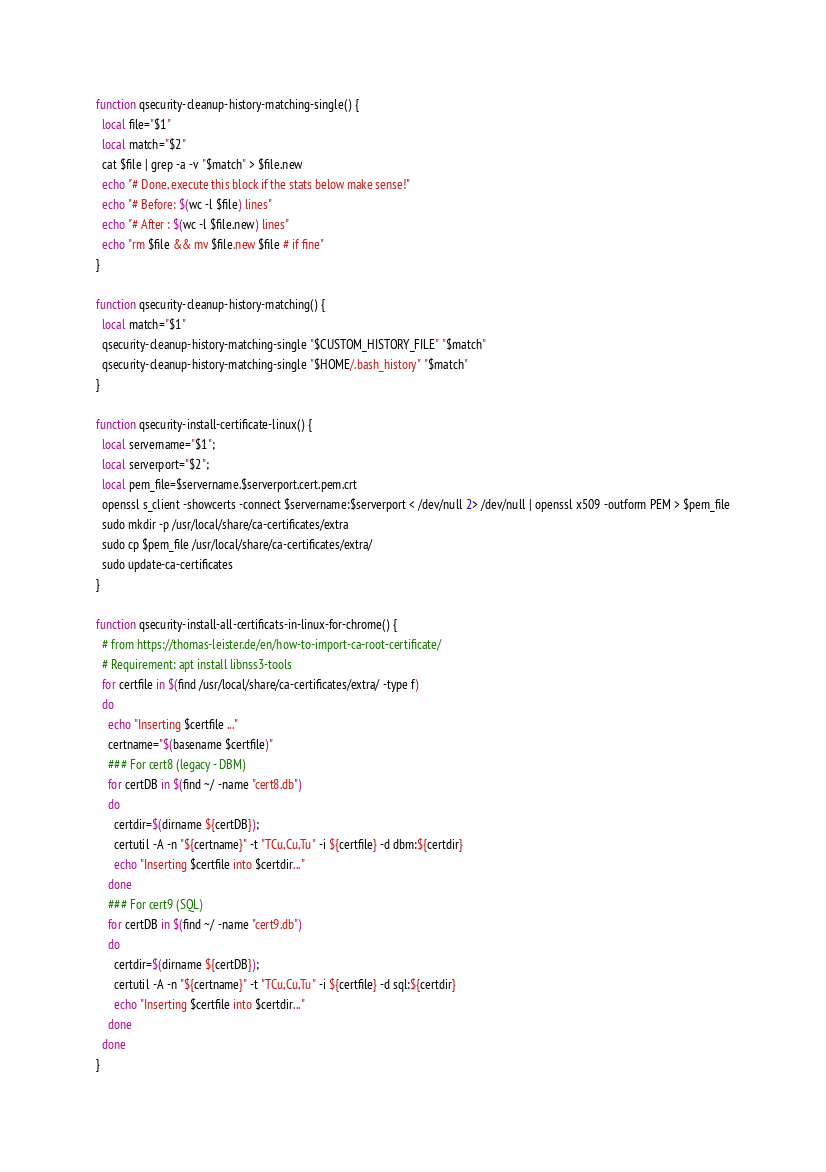<code> <loc_0><loc_0><loc_500><loc_500><_Bash_>function qsecurity-cleanup-history-matching-single() {
  local file="$1"
  local match="$2"
  cat $file | grep -a -v "$match" > $file.new
  echo "# Done, execute this block if the stats below make sense!"
  echo "# Before: $(wc -l $file) lines"
  echo "# After : $(wc -l $file.new) lines"
  echo "rm $file && mv $file.new $file # if fine"
}

function qsecurity-cleanup-history-matching() {
  local match="$1"
  qsecurity-cleanup-history-matching-single "$CUSTOM_HISTORY_FILE" "$match"
  qsecurity-cleanup-history-matching-single "$HOME/.bash_history" "$match"
}

function qsecurity-install-certificate-linux() {
  local servername="$1";
  local serverport="$2";
  local pem_file=$servername.$serverport.cert.pem.crt
  openssl s_client -showcerts -connect $servername:$serverport < /dev/null 2> /dev/null | openssl x509 -outform PEM > $pem_file
  sudo mkdir -p /usr/local/share/ca-certificates/extra
  sudo cp $pem_file /usr/local/share/ca-certificates/extra/
  sudo update-ca-certificates
}

function qsecurity-install-all-certificats-in-linux-for-chrome() {
  # from https://thomas-leister.de/en/how-to-import-ca-root-certificate/
  # Requirement: apt install libnss3-tools
  for certfile in $(find /usr/local/share/ca-certificates/extra/ -type f)
  do
    echo "Inserting $certfile ..."
	certname="$(basename $certfile)"
	### For cert8 (legacy - DBM)
	for certDB in $(find ~/ -name "cert8.db")
	do
	  certdir=$(dirname ${certDB});
	  certutil -A -n "${certname}" -t "TCu,Cu,Tu" -i ${certfile} -d dbm:${certdir}
      echo "Inserting $certfile into $certdir..."
	done
	### For cert9 (SQL)
	for certDB in $(find ~/ -name "cert9.db")
	do
	  certdir=$(dirname ${certDB});
	  certutil -A -n "${certname}" -t "TCu,Cu,Tu" -i ${certfile} -d sql:${certdir}
      echo "Inserting $certfile into $certdir..."
	done
  done
}
</code> 